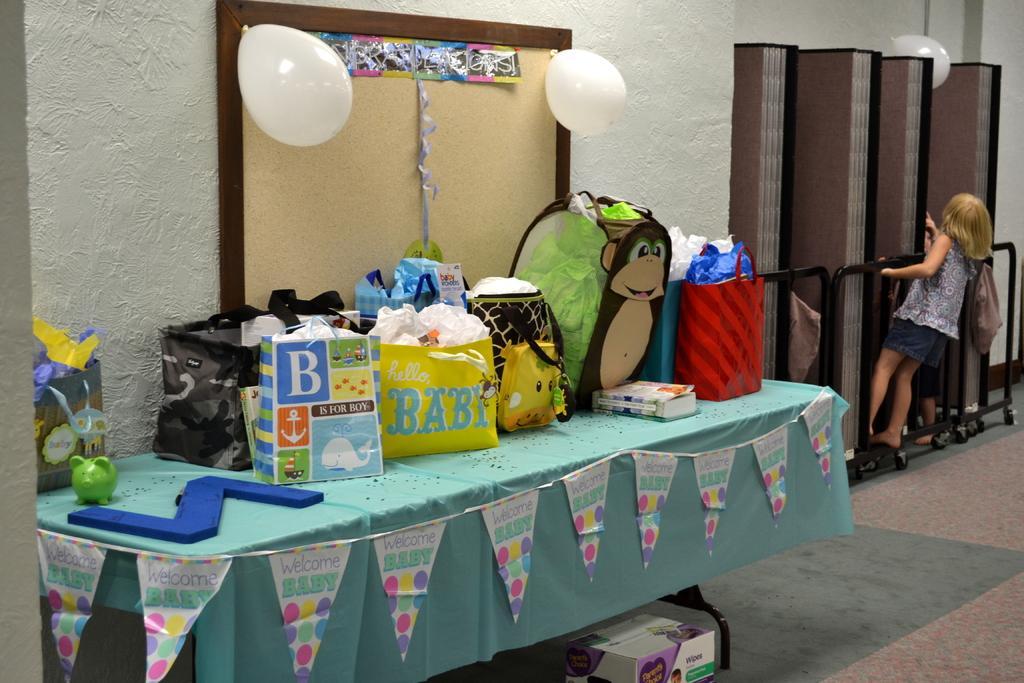Please provide a concise description of this image. In this image, There is a table which is covered by a blue color cloth and on that table there are some bags and there is a object which is in dark blue color, In the right side there is girl standing and holding a black color door, in the background there is a wall of white color and there a brown color door and there two balloons in white color. 